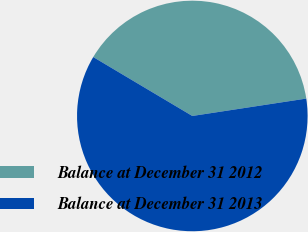<chart> <loc_0><loc_0><loc_500><loc_500><pie_chart><fcel>Balance at December 31 2012<fcel>Balance at December 31 2013<nl><fcel>39.05%<fcel>60.95%<nl></chart> 